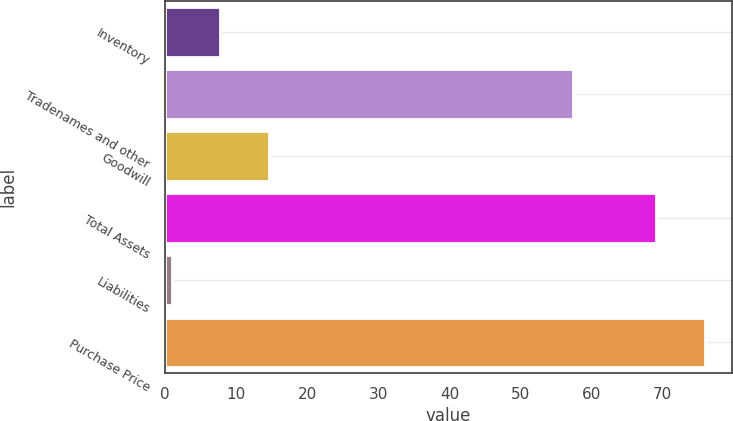Convert chart to OTSL. <chart><loc_0><loc_0><loc_500><loc_500><bar_chart><fcel>Inventory<fcel>Tradenames and other<fcel>Goodwill<fcel>Total Assets<fcel>Liabilities<fcel>Purchase Price<nl><fcel>7.8<fcel>57.4<fcel>14.61<fcel>69.1<fcel>0.99<fcel>75.91<nl></chart> 